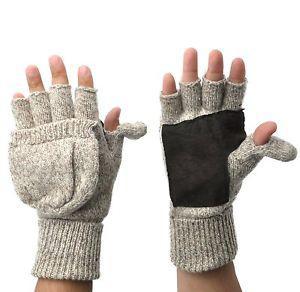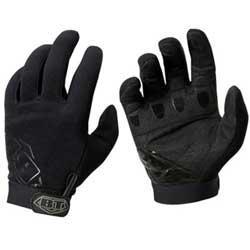The first image is the image on the left, the second image is the image on the right. Evaluate the accuracy of this statement regarding the images: "There are two gloves without fingers.". Is it true? Answer yes or no. Yes. The first image is the image on the left, the second image is the image on the right. Considering the images on both sides, is "Each pair of mittens includes at least one with a rounded covered top, and no mitten has four full-length fingers with tips." valid? Answer yes or no. No. 